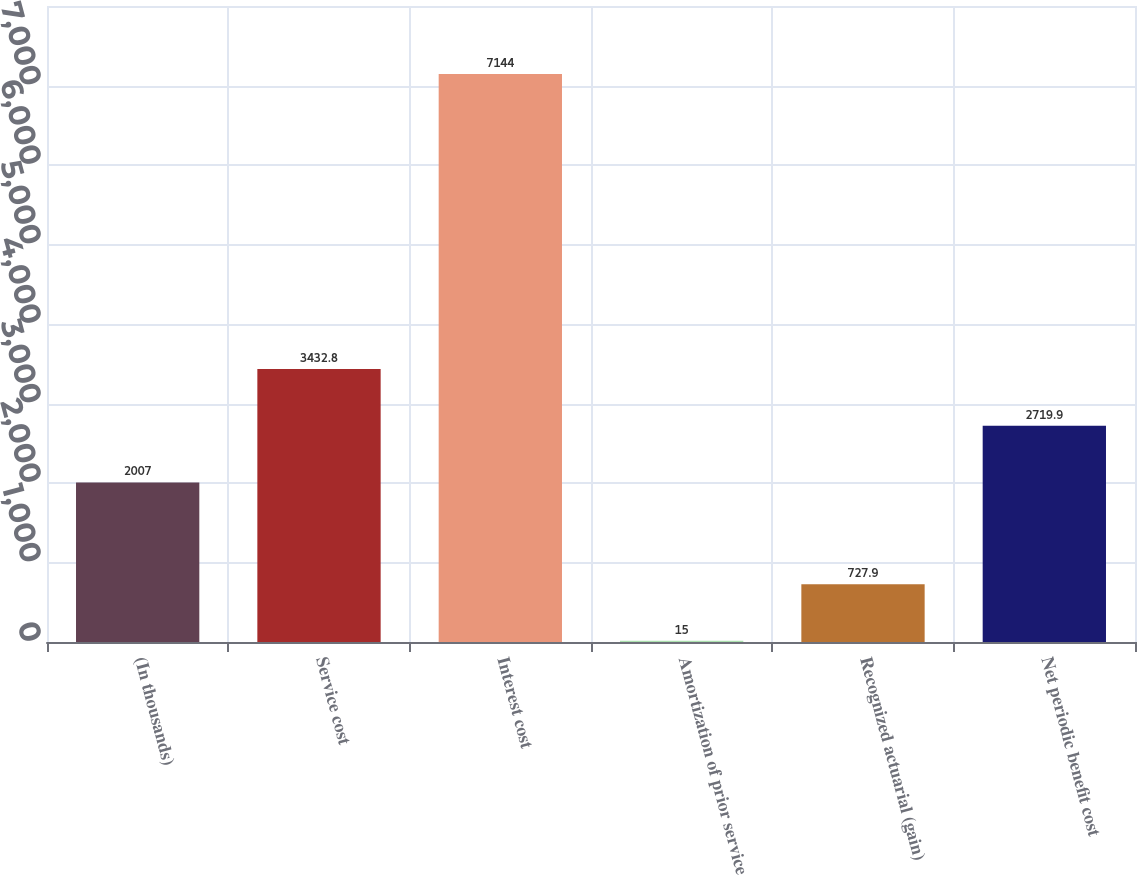<chart> <loc_0><loc_0><loc_500><loc_500><bar_chart><fcel>(In thousands)<fcel>Service cost<fcel>Interest cost<fcel>Amortization of prior service<fcel>Recognized actuarial (gain)<fcel>Net periodic benefit cost<nl><fcel>2007<fcel>3432.8<fcel>7144<fcel>15<fcel>727.9<fcel>2719.9<nl></chart> 